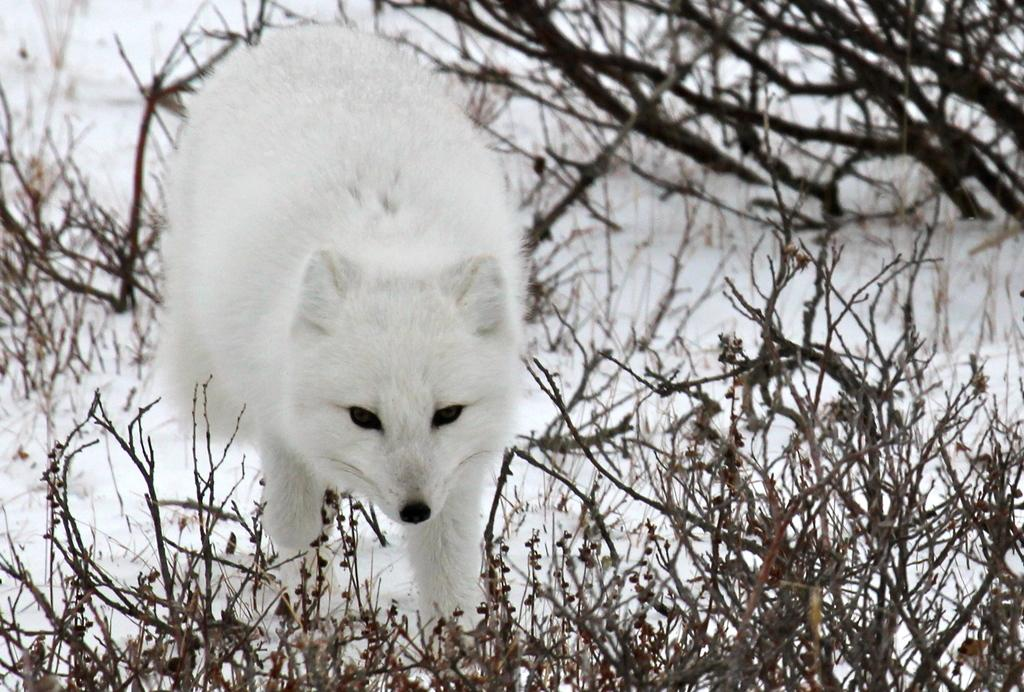What animal is the main subject of the image? There is an arctic fox in the image. What is the arctic fox doing in the image? The arctic fox is walking in the image. What can be seen in the background of the image? There are trees and snow in the background of the image. What is the weight of the wind in the image? There is no wind present in the image, and therefore no weight can be assigned to it. 